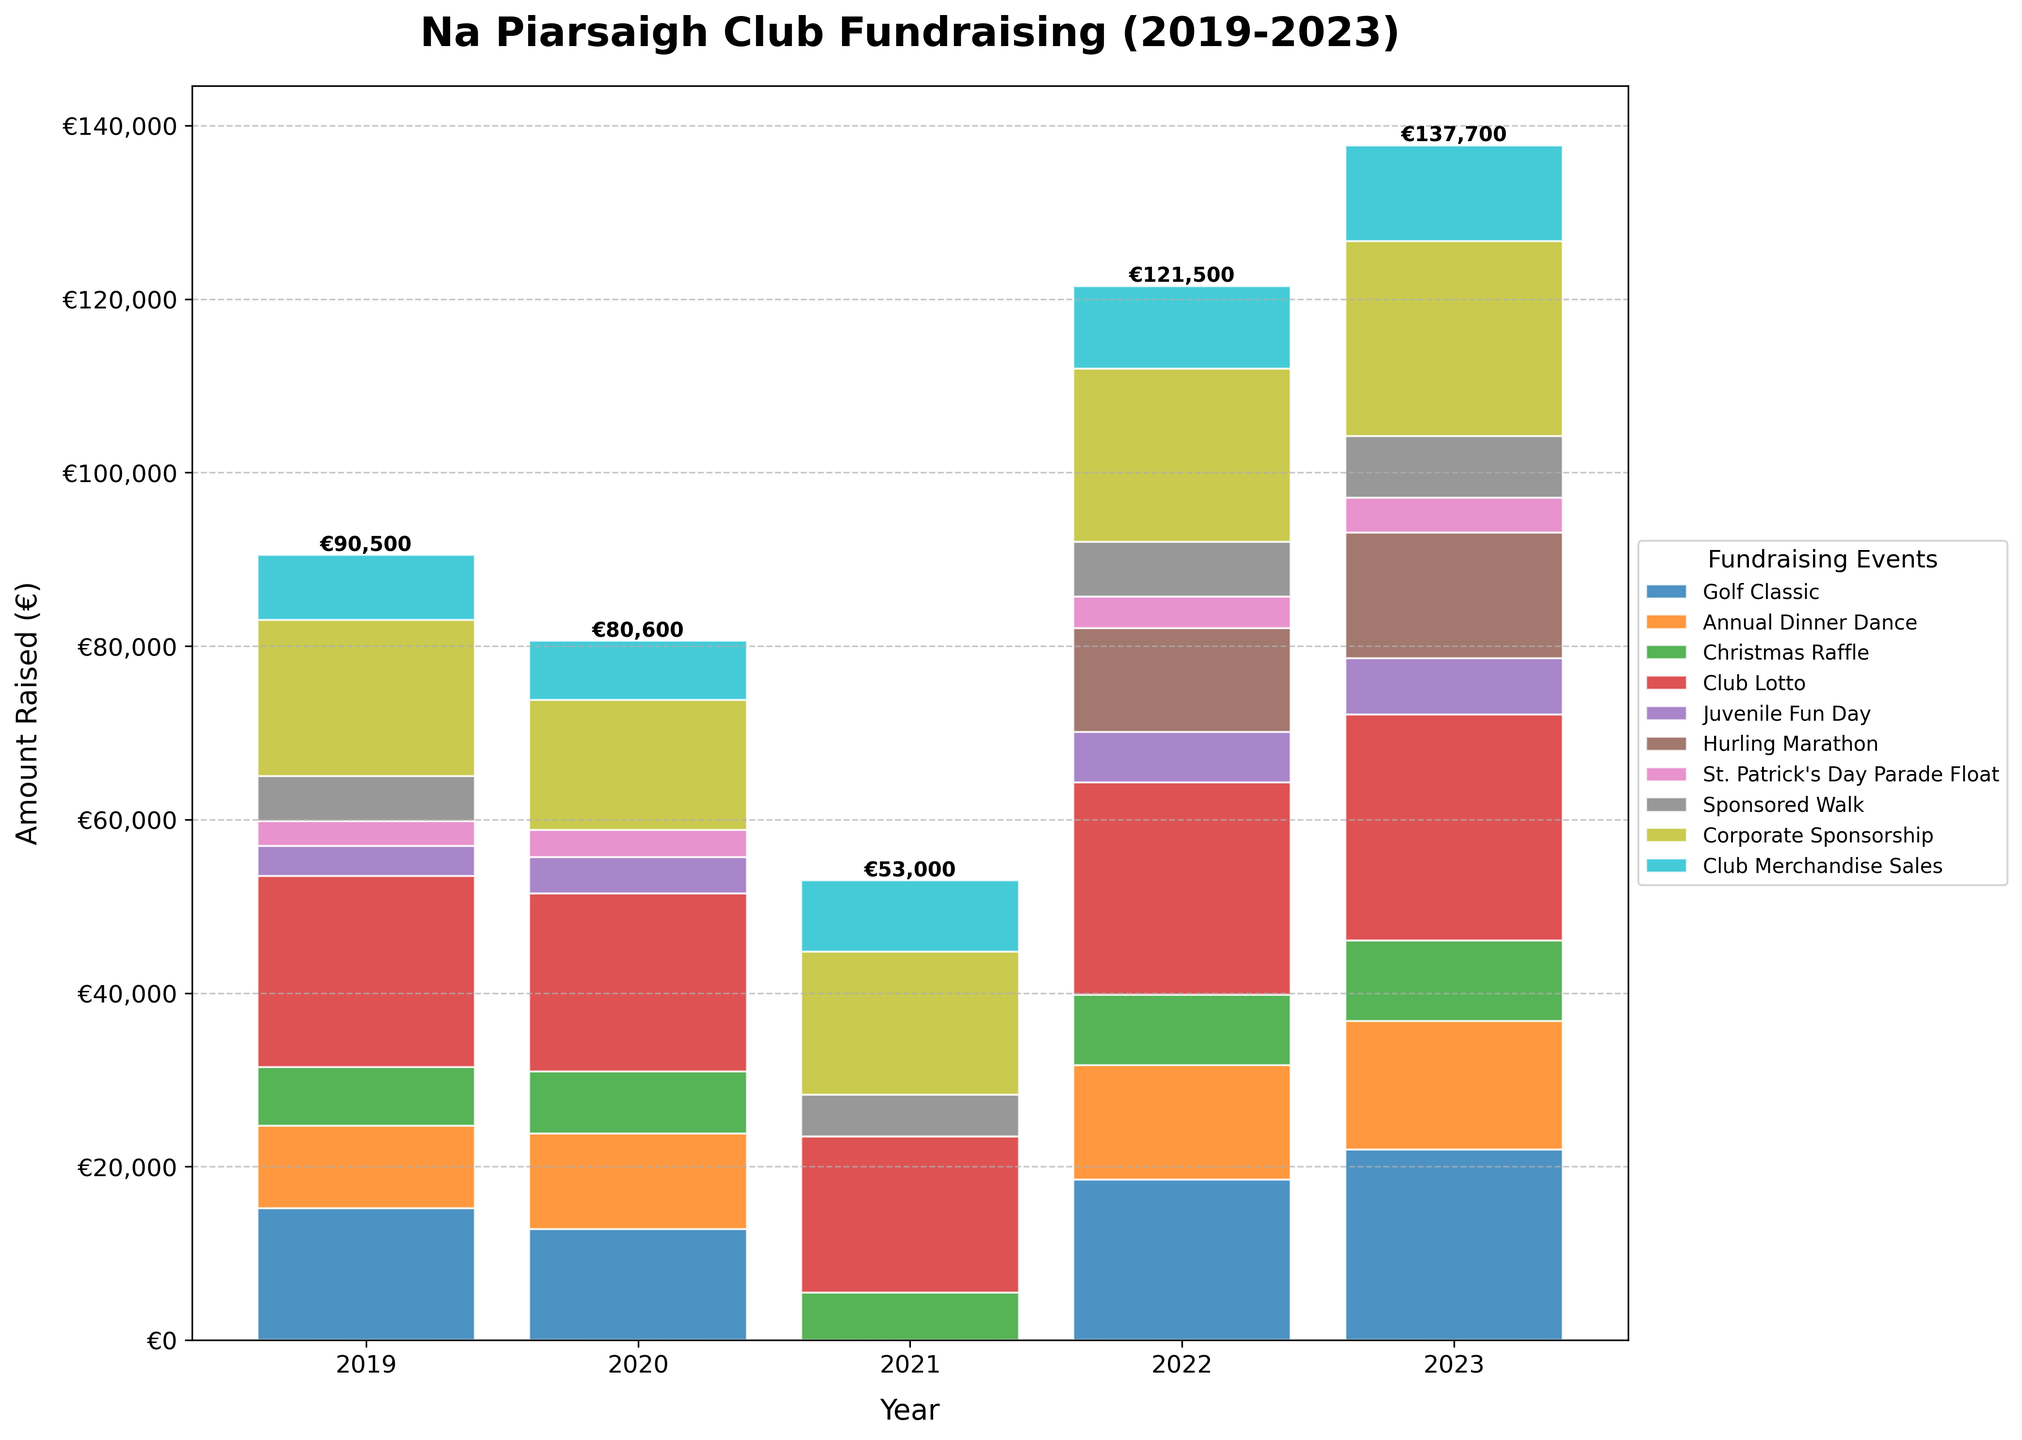Which event type raised the most funds in 2023? Look at the heights of the bars for the year 2023. The Club Lotto bar is the highest.
Answer: Club Lotto How much more did the Golf Classic raise in 2023 compared to 2021? Subtract the amount for Golf Classic in 2021 from the amount in 2023. So, €22,000 - €0 = €22,000.
Answer: €22,000 What is the total amount raised by Corporate Sponsorship over the five years? Sum the Corporate Sponsorship amounts from each year: €18,000 + €15,000 + €16,500 + €20,000 + €22,500 = €92,000.
Answer: €92,000 Which year had the lowest total fundraising and how much was it? Sum up the heights of all bars for each year and compare. 2021 has the lowest total with €0 + €0 + €5,500 + €18,000 + €0 + €0 + €0 + €4,800 + €16,500 + €8,200 = €53,000.
Answer: 2021, €53,000 How did the amount raised by Club Merchandise Sales change from 2020 to 2023? Subtract the amount in 2020 from the amount in 2023 for Club Merchandise Sales. So, €11,000 - €6,800 = €4,200.
Answer: Increased by €4,200 Which event type had no fundraising activity in 2021? Look at the bars for 2021 and find the event types that correspond to zero heights. These events are Golf Classic, Annual Dinner Dance, Juvenile Fun Day, and St. Patrick's Day Parade Float, and Hurling Marathon.
Answer: Golf Classic, Annual Dinner Dance, Juvenile Fun Day, St. Patrick's Day Parade Float, Hurling Marathon Between which two consecutive years did the total fundraising see the greatest increase? Calculate the total for each year and find the differences between consecutive years. The greatest increase is from 2021 (€53,000) to 2022 (€146,000), a difference of €93,000.
Answer: Between 2021 and 2022 What was the average amount raised by the Annual Dinner Dance from 2019 to 2023? Sum the Annual Dinner Dance amounts and divide by 5: (€9,500 + €11,200 + €0 + €13,200 + €14,800) / 5 = €48,700 / 5 = €9,740.
Answer: €9,740 Which two events switched ranking positions (based on amount raised) between 2019 and 2023? Compare the rankings of event types between 2019 and 2023 by their amount raised. Christmas Raffle and Juvenile Fun Day switched positions: Christmas Raffle was higher in 2019 but lower in 2023 while Juvenile Fun Day was lower in 2019 but higher in 2023.
Answer: Christmas Raffle and Juvenile Fun Day 